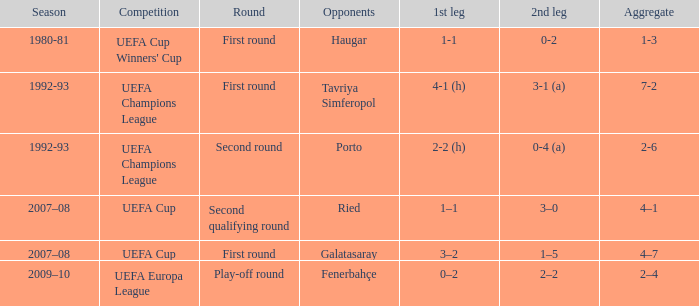What's the combined score when the 1st leg is 3-2? 4–7. 